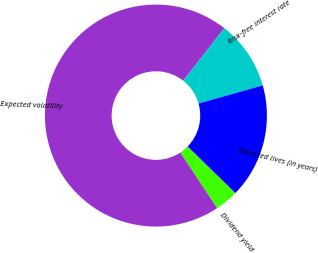Convert chart to OTSL. <chart><loc_0><loc_0><loc_500><loc_500><pie_chart><fcel>Dividend yield<fcel>Expected volatility<fcel>Risk-free interest rate<fcel>Expected lives (in years)<nl><fcel>3.41%<fcel>69.85%<fcel>10.05%<fcel>16.68%<nl></chart> 